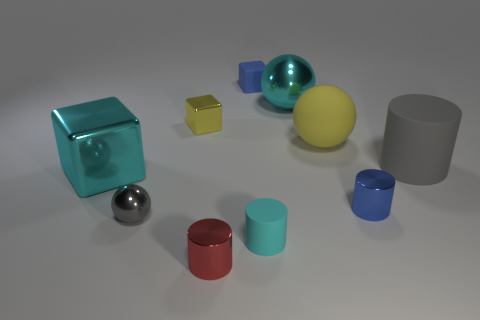Subtract all small cyan cylinders. How many cylinders are left? 3 Subtract all blue cubes. How many cubes are left? 2 Subtract all cylinders. How many objects are left? 6 Subtract 2 cylinders. How many cylinders are left? 2 Add 1 tiny cyan shiny cylinders. How many tiny cyan shiny cylinders exist? 1 Subtract 0 green cubes. How many objects are left? 10 Subtract all red cylinders. Subtract all cyan balls. How many cylinders are left? 3 Subtract all big red rubber cylinders. Subtract all large rubber things. How many objects are left? 8 Add 7 red things. How many red things are left? 8 